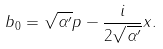Convert formula to latex. <formula><loc_0><loc_0><loc_500><loc_500>b _ { 0 } = \sqrt { \alpha ^ { \prime } } p - \frac { i } { 2 \sqrt { \alpha ^ { \prime } } } x .</formula> 